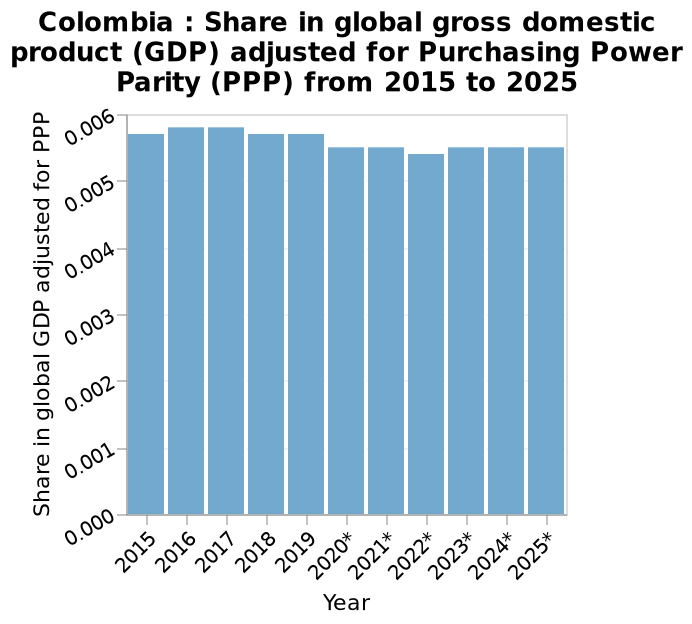<image>
What type of data is represented by the bar graph? The bar graph represents the share of Colombia in the global gross domestic product (GDP) adjusted for Purchasing Power Parity (PPP) from 2015 to 2025. please summary the statistics and relations of the chart Columbias highest share of GPD was in 2016 and 2017. Their lowest share is in 2022. Was Columbia's highest share of GDP in 2018? No, Columbia's highest share of GDP was in 2016 and 2017, not in 2018. In which years did Columbia have its highest share of GDP?  Columbia had its highest share of GDP in 2016 and 2017. 